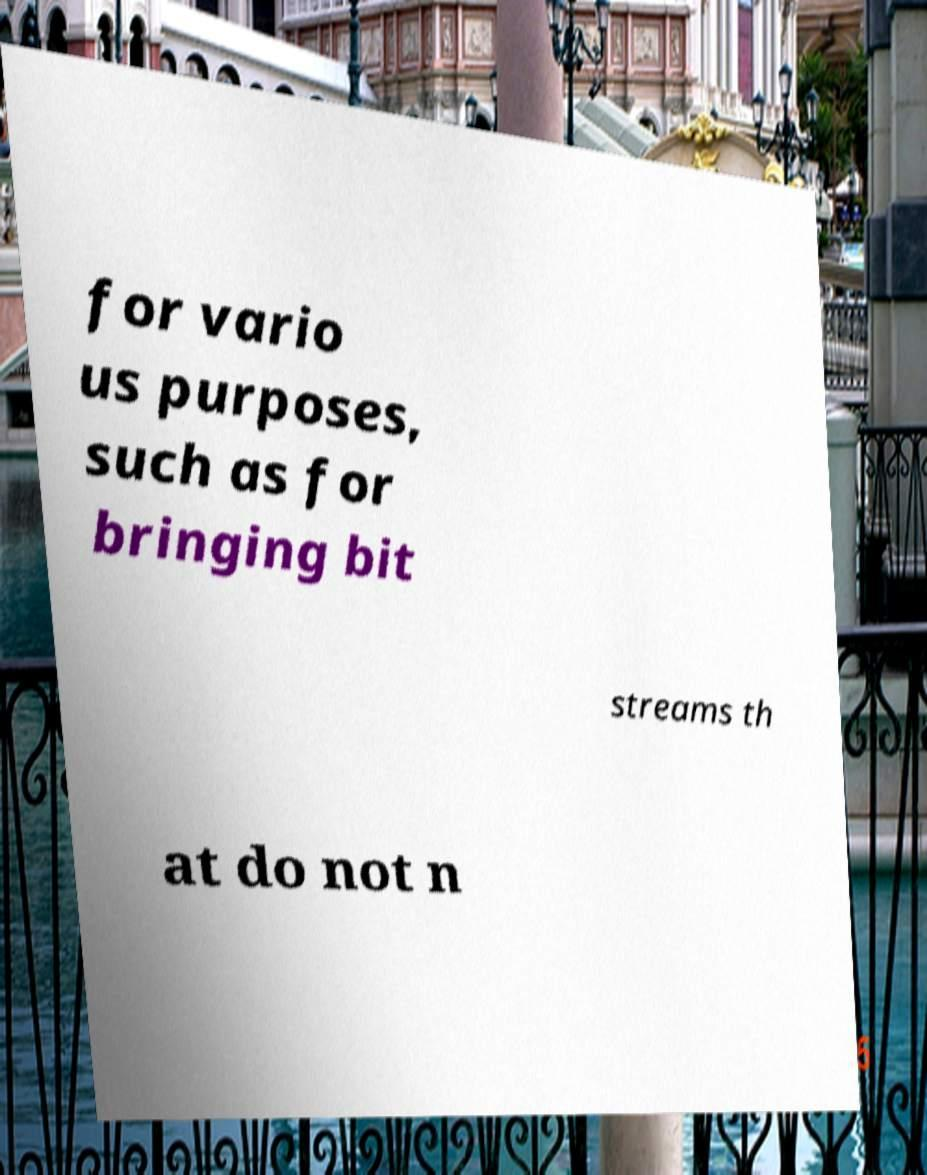Could you extract and type out the text from this image? for vario us purposes, such as for bringing bit streams th at do not n 